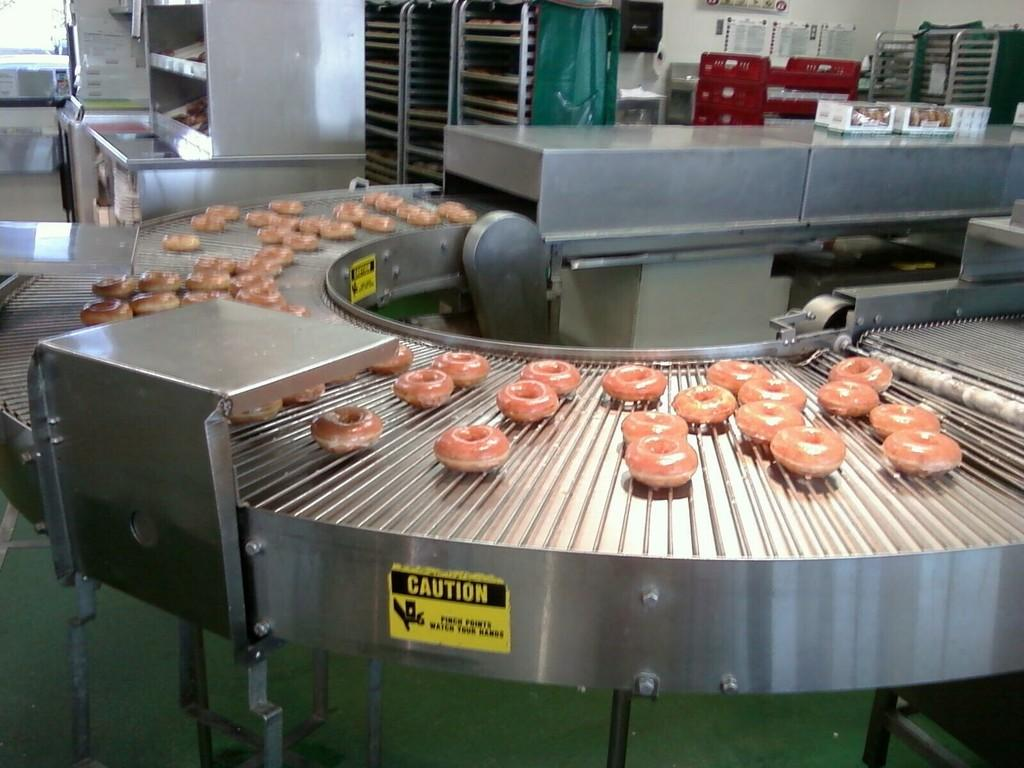<image>
Relay a brief, clear account of the picture shown. a bunch of doughnuts on a conveyer belt with a yellow caution sticker 